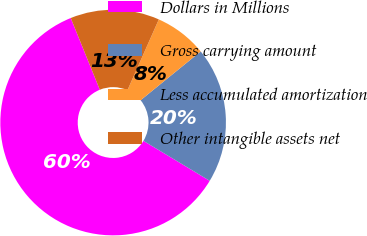Convert chart. <chart><loc_0><loc_0><loc_500><loc_500><pie_chart><fcel>Dollars in Millions<fcel>Gross carrying amount<fcel>Less accumulated amortization<fcel>Other intangible assets net<nl><fcel>60.23%<fcel>19.5%<fcel>7.5%<fcel>12.77%<nl></chart> 